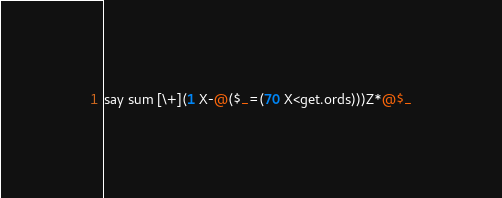Convert code to text. <code><loc_0><loc_0><loc_500><loc_500><_Perl_>say sum [\+](1 X-@($_=(70 X<get.ords)))Z*@$_</code> 